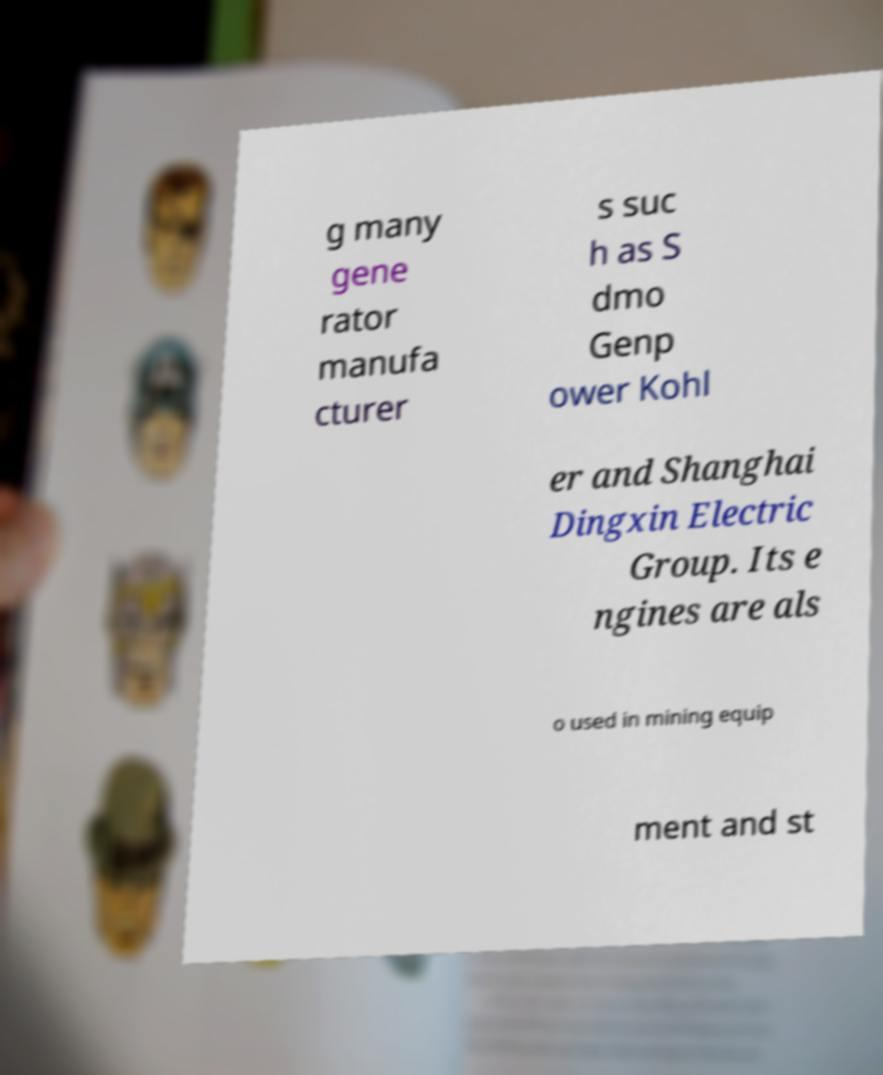For documentation purposes, I need the text within this image transcribed. Could you provide that? g many gene rator manufa cturer s suc h as S dmo Genp ower Kohl er and Shanghai Dingxin Electric Group. Its e ngines are als o used in mining equip ment and st 